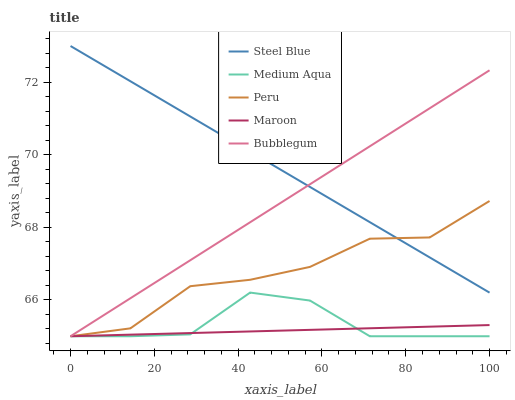Does Maroon have the minimum area under the curve?
Answer yes or no. Yes. Does Steel Blue have the maximum area under the curve?
Answer yes or no. Yes. Does Bubblegum have the minimum area under the curve?
Answer yes or no. No. Does Bubblegum have the maximum area under the curve?
Answer yes or no. No. Is Maroon the smoothest?
Answer yes or no. Yes. Is Medium Aqua the roughest?
Answer yes or no. Yes. Is Bubblegum the smoothest?
Answer yes or no. No. Is Bubblegum the roughest?
Answer yes or no. No. Does Maroon have the lowest value?
Answer yes or no. Yes. Does Steel Blue have the lowest value?
Answer yes or no. No. Does Steel Blue have the highest value?
Answer yes or no. Yes. Does Bubblegum have the highest value?
Answer yes or no. No. Is Maroon less than Steel Blue?
Answer yes or no. Yes. Is Steel Blue greater than Medium Aqua?
Answer yes or no. Yes. Does Maroon intersect Bubblegum?
Answer yes or no. Yes. Is Maroon less than Bubblegum?
Answer yes or no. No. Is Maroon greater than Bubblegum?
Answer yes or no. No. Does Maroon intersect Steel Blue?
Answer yes or no. No. 